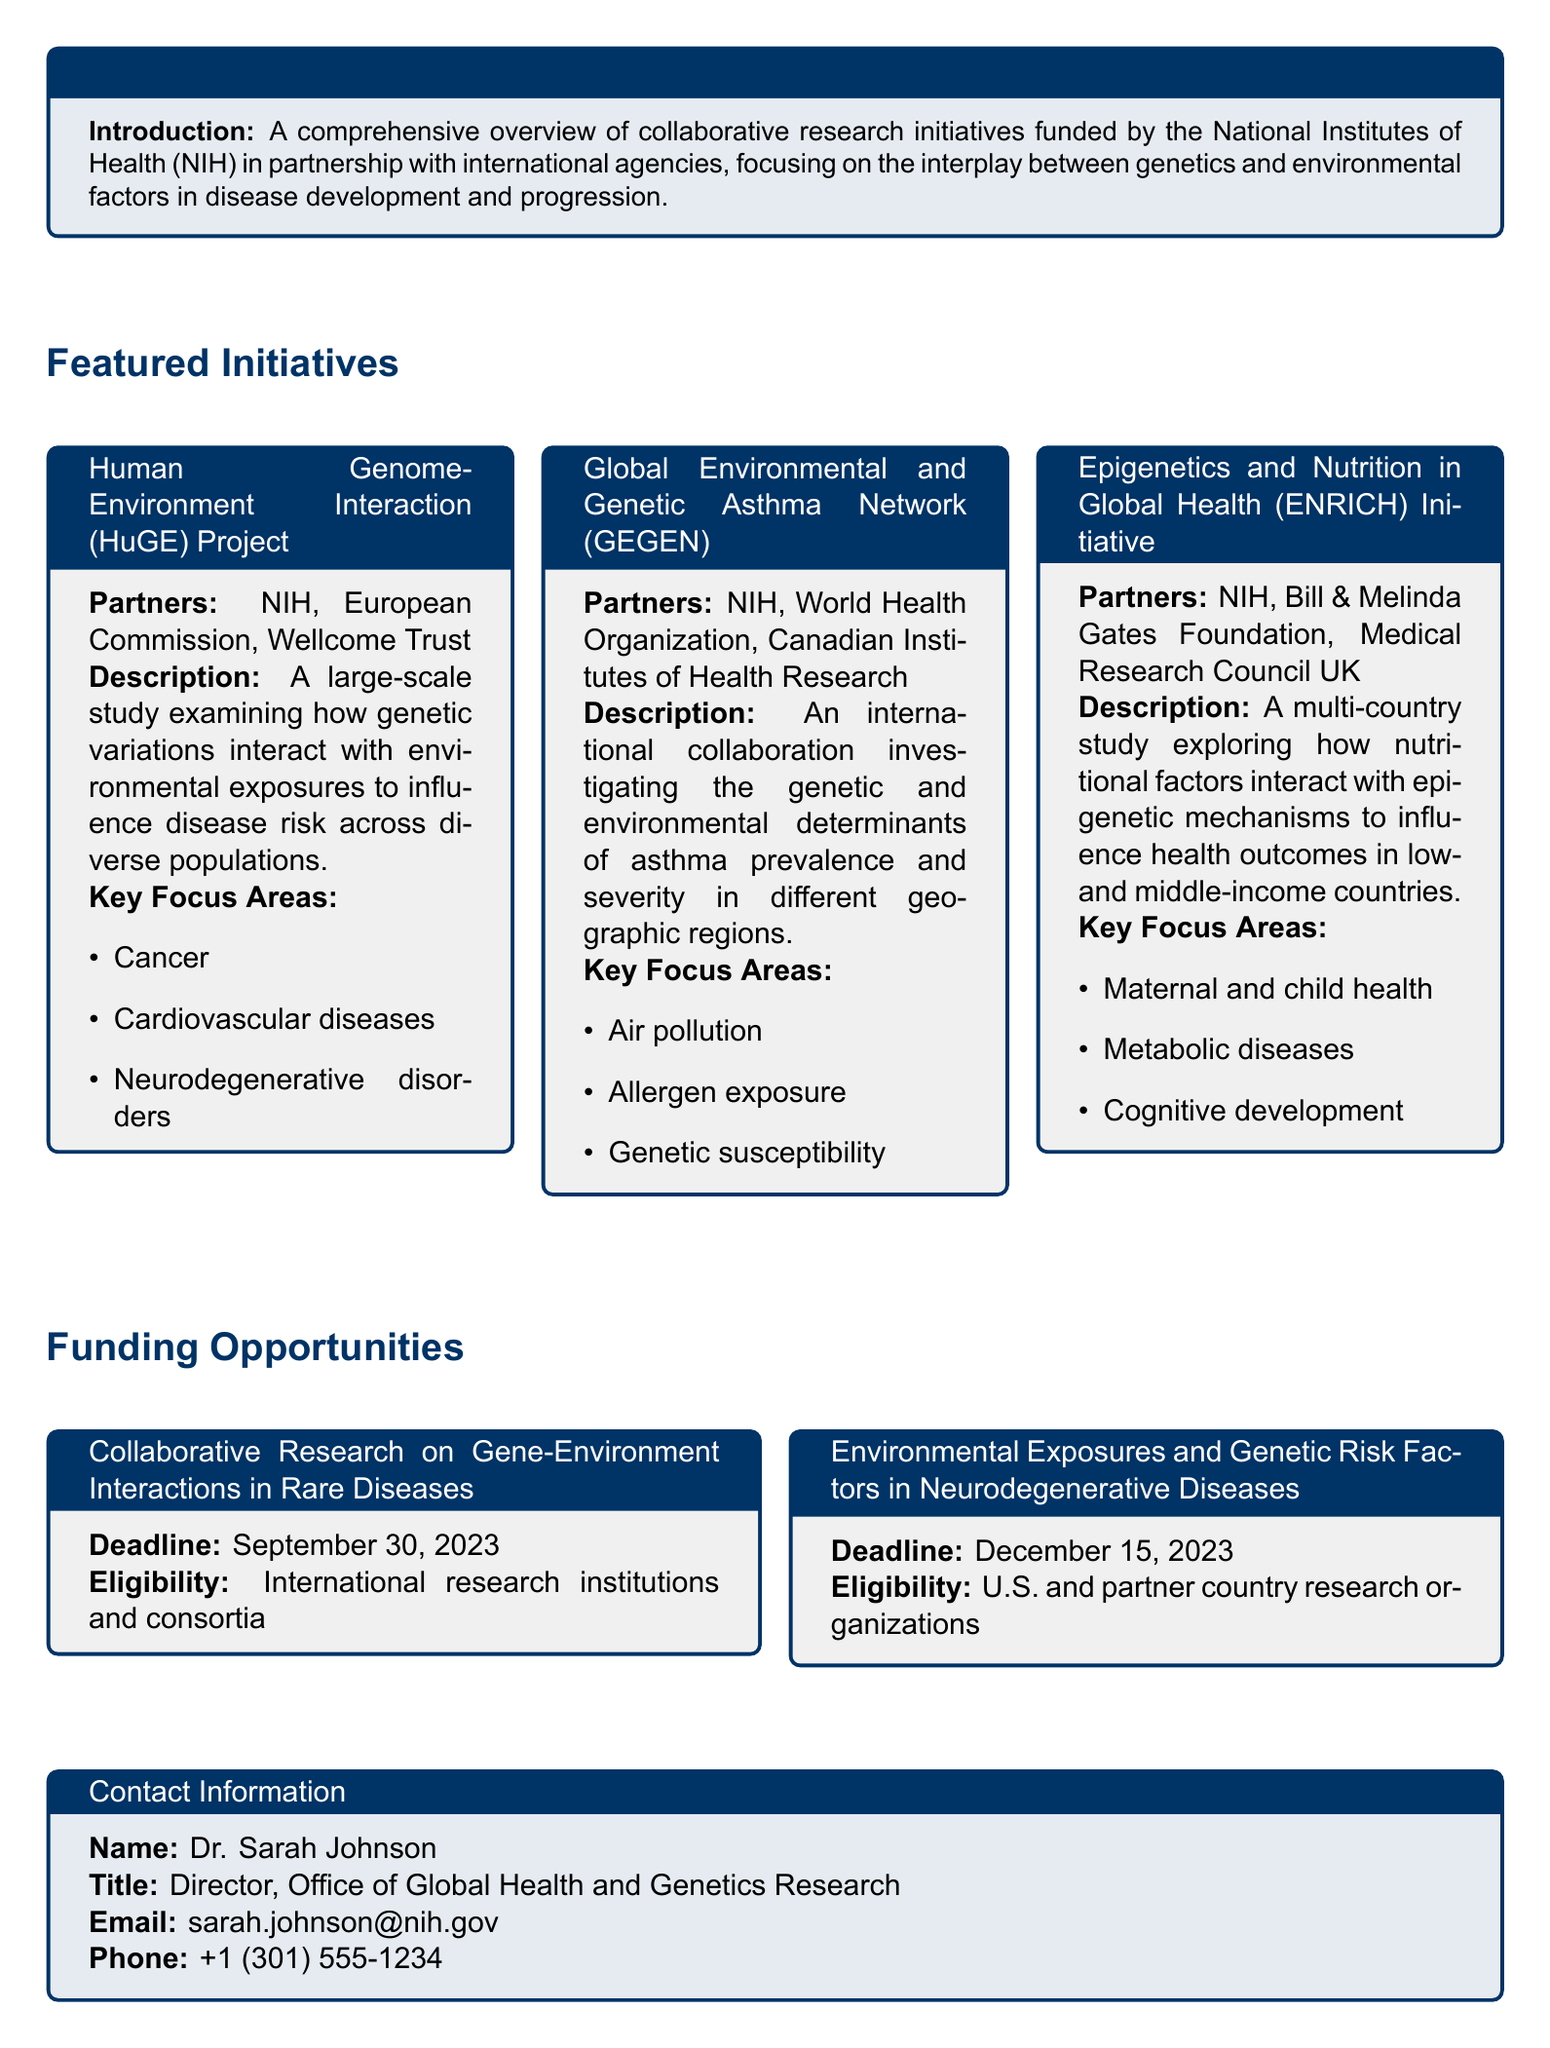What is the title of the catalog? The title of the catalog is mentioned at the beginning and is "Global Genetics and Environmental Health Research Initiatives."
Answer: Global Genetics and Environmental Health Research Initiatives Who are the partners in the HuGE Project? The partners involved in the HuGE Project include the NIH, European Commission, and Wellcome Trust.
Answer: NIH, European Commission, Wellcome Trust What is the key focus area of the GEGEN initiative related to environmental aspects? One of the key focus areas of the GEGEN initiative is air pollution, which is an environmental factor.
Answer: Air pollution What is the deadline for the Collaborative Research on Gene-Environment Interactions in Rare Diseases? The deadline for submitting proposals for this initiative is stated in the funding opportunities section of the document.
Answer: September 30, 2023 Which organization is not listed as a partner for the ENRICH initiative? The question requires identifying partners associated with the ENRICH initiative and determining which organization is not mentioned.
Answer: World Health Organization What aspect of health does the ENRICH initiative focus on in low- and middle-income countries? The ENRICH initiative focuses on how nutritional factors affect health outcomes, notably in maternal and child health.
Answer: Maternal and child health Who is the director of the Office of Global Health and Genetics Research? The contact information section includes the name and title of the director for this office.
Answer: Dr. Sarah Johnson Which agencies are mentioned as partners in the GEGEN initiative? The GEGEN initiative features partnerships with the NIH, World Health Organization, and Canadian Institutes of Health Research.
Answer: NIH, World Health Organization, Canadian Institutes of Health Research 